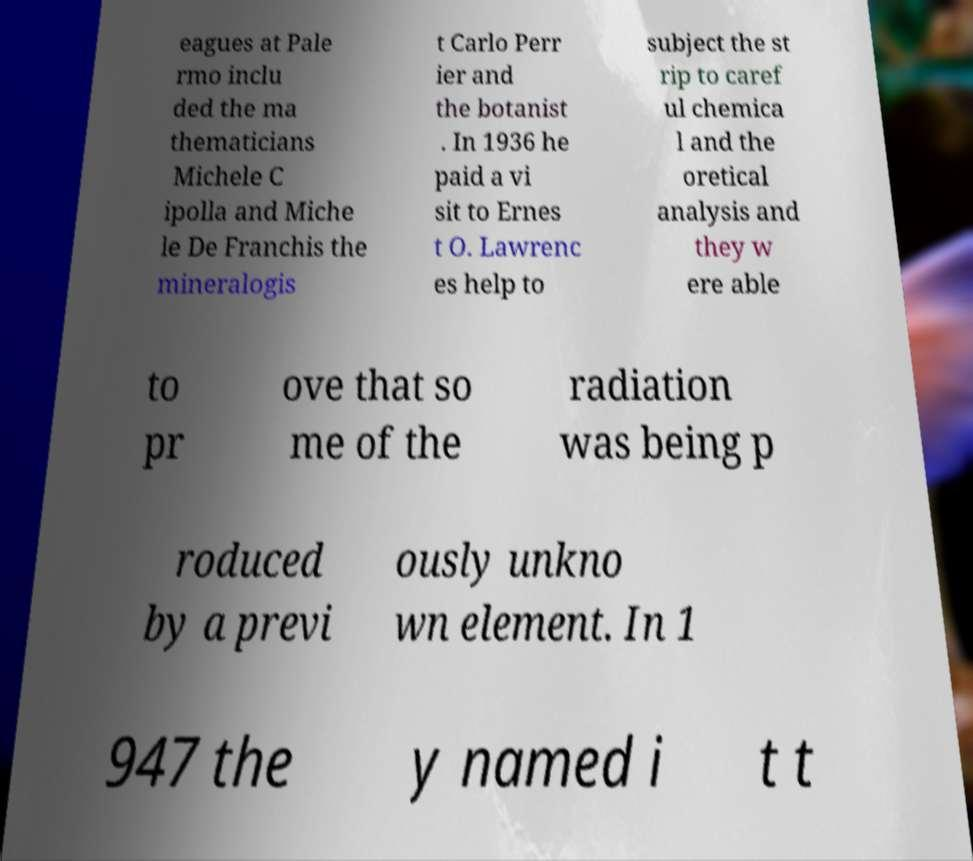There's text embedded in this image that I need extracted. Can you transcribe it verbatim? eagues at Pale rmo inclu ded the ma thematicians Michele C ipolla and Miche le De Franchis the mineralogis t Carlo Perr ier and the botanist . In 1936 he paid a vi sit to Ernes t O. Lawrenc es help to subject the st rip to caref ul chemica l and the oretical analysis and they w ere able to pr ove that so me of the radiation was being p roduced by a previ ously unkno wn element. In 1 947 the y named i t t 